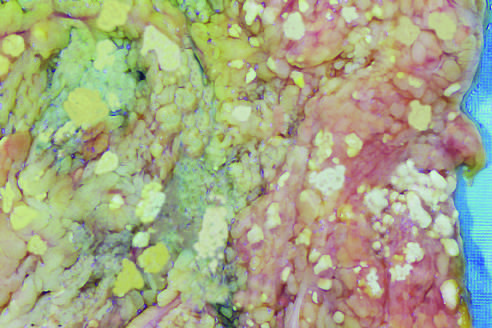where do areas of white chalky deposits represent foci of fat necrosis with calcium soap formation?
Answer the question using a single word or phrase. At sites of lipid breakdown in the mesentery 